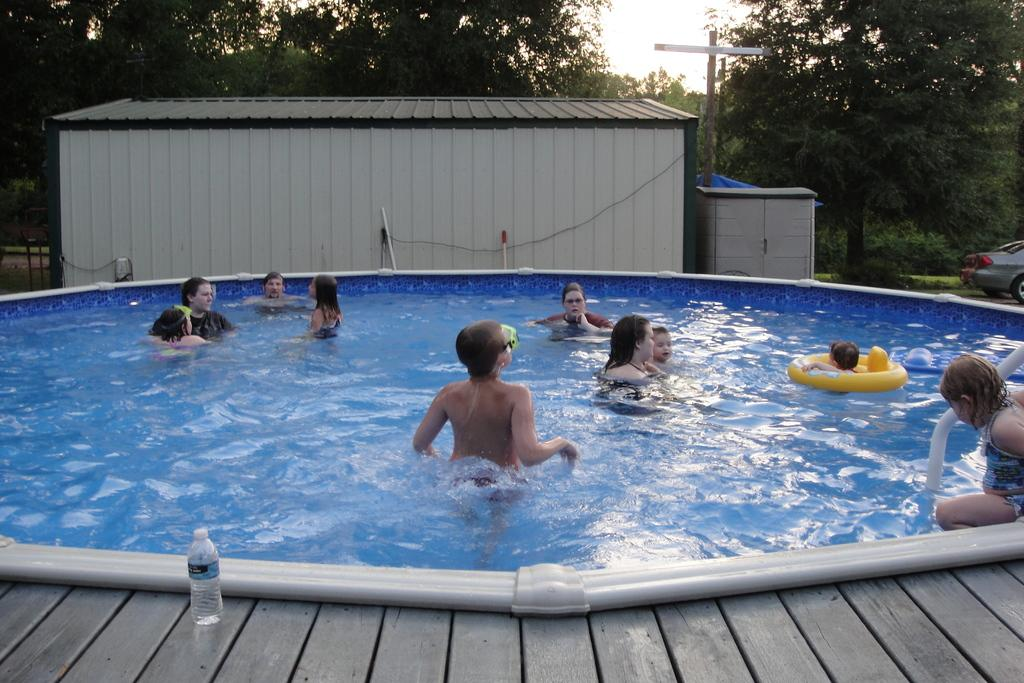What is the main feature of the image? There is a swimming pool in the image. What is the person in the image doing? A person is swimming in the pool. What can be seen in the sky in the image? The sky is visible in the image. What type of vegetation is present in the image? Trees are present in the image. What type of structure is visible in the image? There is a house in the image. What else can be seen in the image besides the swimming pool and the person? A vehicle is visible in the image. How many hands are visible in the image? There is no mention of hands in the image, so it is impossible to determine how many are visible. 